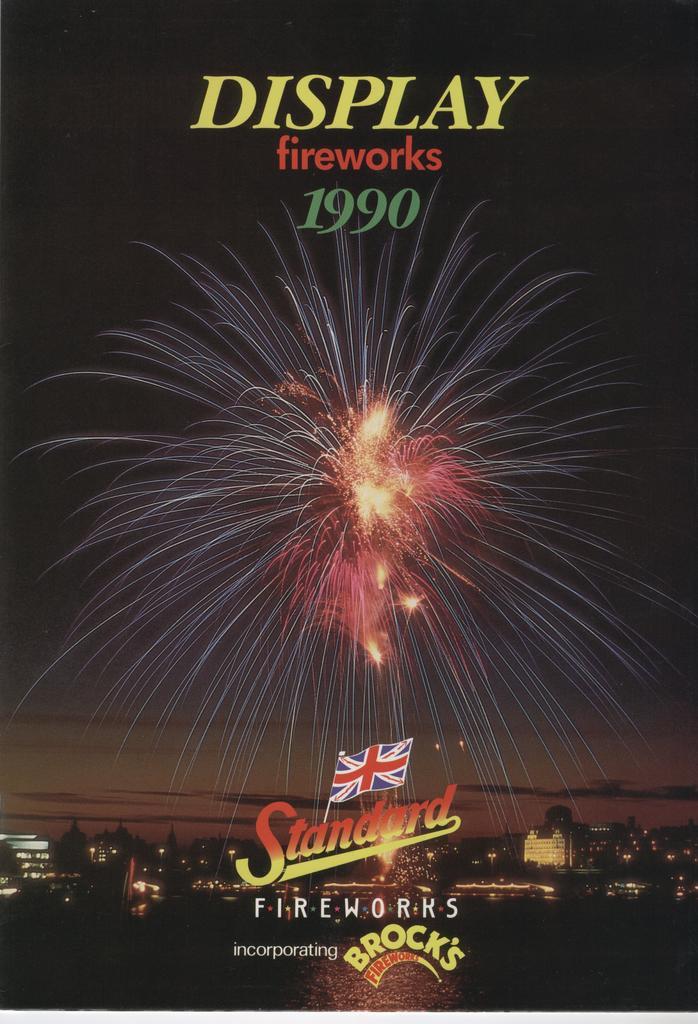What year is this poster for?
Offer a terse response. 1990. What is the brand?
Keep it short and to the point. Standard fireworks. 